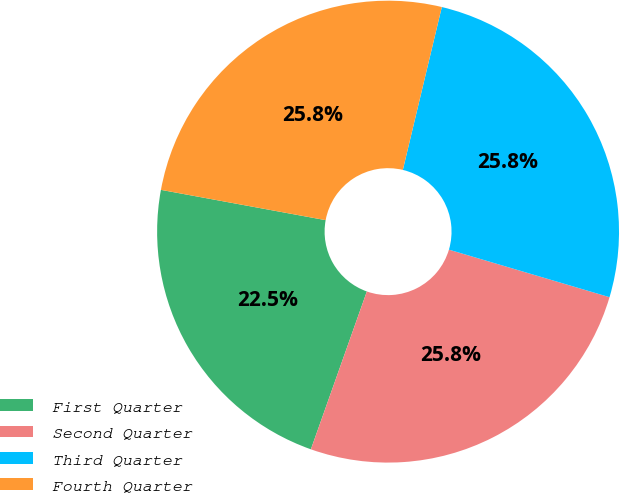Convert chart to OTSL. <chart><loc_0><loc_0><loc_500><loc_500><pie_chart><fcel>First Quarter<fcel>Second Quarter<fcel>Third Quarter<fcel>Fourth Quarter<nl><fcel>22.47%<fcel>25.84%<fcel>25.84%<fcel>25.84%<nl></chart> 